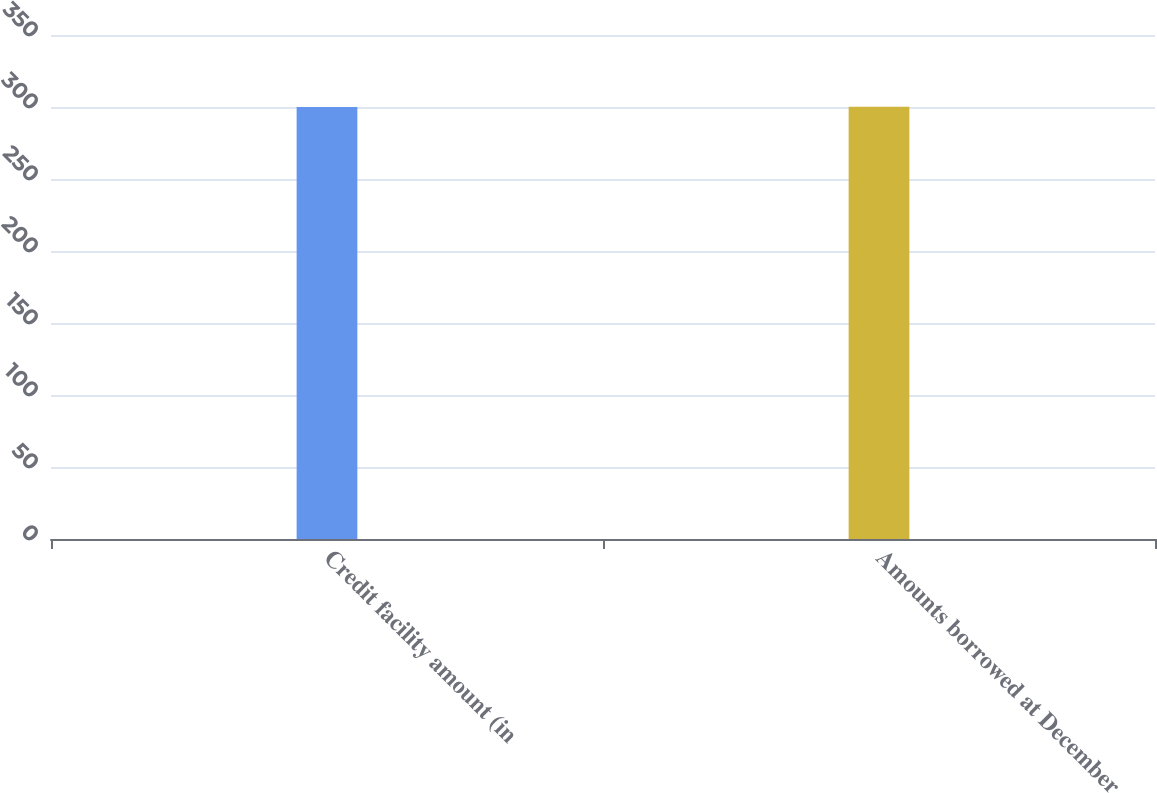<chart> <loc_0><loc_0><loc_500><loc_500><bar_chart><fcel>Credit facility amount (in<fcel>Amounts borrowed at December<nl><fcel>300<fcel>300.2<nl></chart> 